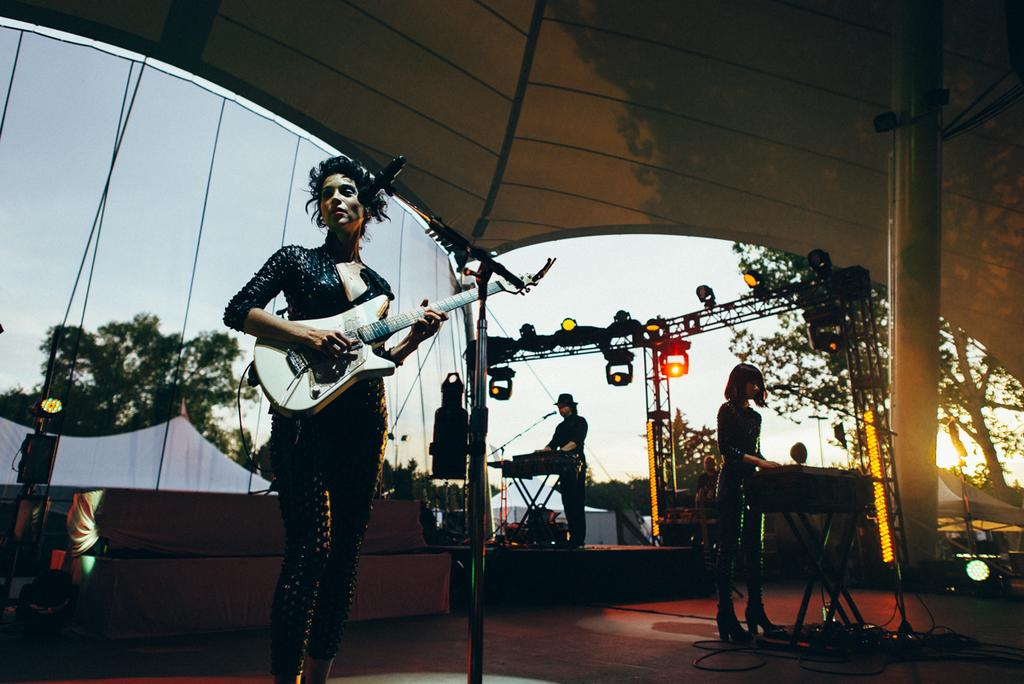What can be seen in the image that provides light? There is a light in the image. What type of pole is present in the image? There is a current pole in the image. Are there any people visible in the image? Yes, there are people standing in the image. What is the woman in the image holding? A woman is holding a guitar in the image. What type of soda is the woman drinking in the image? There is no soda present in the image; the woman is holding a guitar. What type of oatmeal is being served to the people in the image? There is no oatmeal present in the image; the focus is on the light, current pole, people, and the woman with a guitar. 